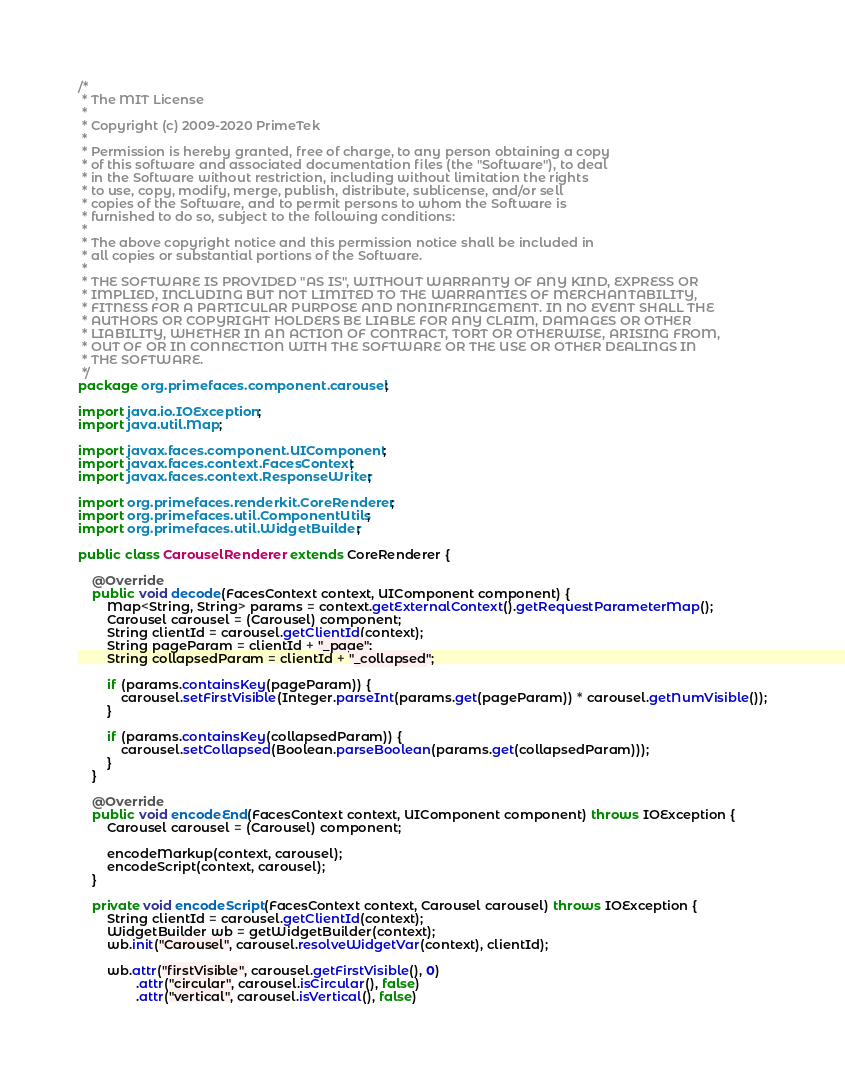<code> <loc_0><loc_0><loc_500><loc_500><_Java_>/*
 * The MIT License
 *
 * Copyright (c) 2009-2020 PrimeTek
 *
 * Permission is hereby granted, free of charge, to any person obtaining a copy
 * of this software and associated documentation files (the "Software"), to deal
 * in the Software without restriction, including without limitation the rights
 * to use, copy, modify, merge, publish, distribute, sublicense, and/or sell
 * copies of the Software, and to permit persons to whom the Software is
 * furnished to do so, subject to the following conditions:
 *
 * The above copyright notice and this permission notice shall be included in
 * all copies or substantial portions of the Software.
 *
 * THE SOFTWARE IS PROVIDED "AS IS", WITHOUT WARRANTY OF ANY KIND, EXPRESS OR
 * IMPLIED, INCLUDING BUT NOT LIMITED TO THE WARRANTIES OF MERCHANTABILITY,
 * FITNESS FOR A PARTICULAR PURPOSE AND NONINFRINGEMENT. IN NO EVENT SHALL THE
 * AUTHORS OR COPYRIGHT HOLDERS BE LIABLE FOR ANY CLAIM, DAMAGES OR OTHER
 * LIABILITY, WHETHER IN AN ACTION OF CONTRACT, TORT OR OTHERWISE, ARISING FROM,
 * OUT OF OR IN CONNECTION WITH THE SOFTWARE OR THE USE OR OTHER DEALINGS IN
 * THE SOFTWARE.
 */
package org.primefaces.component.carousel;

import java.io.IOException;
import java.util.Map;

import javax.faces.component.UIComponent;
import javax.faces.context.FacesContext;
import javax.faces.context.ResponseWriter;

import org.primefaces.renderkit.CoreRenderer;
import org.primefaces.util.ComponentUtils;
import org.primefaces.util.WidgetBuilder;

public class CarouselRenderer extends CoreRenderer {

    @Override
    public void decode(FacesContext context, UIComponent component) {
        Map<String, String> params = context.getExternalContext().getRequestParameterMap();
        Carousel carousel = (Carousel) component;
        String clientId = carousel.getClientId(context);
        String pageParam = clientId + "_page";
        String collapsedParam = clientId + "_collapsed";

        if (params.containsKey(pageParam)) {
            carousel.setFirstVisible(Integer.parseInt(params.get(pageParam)) * carousel.getNumVisible());
        }

        if (params.containsKey(collapsedParam)) {
            carousel.setCollapsed(Boolean.parseBoolean(params.get(collapsedParam)));
        }
    }

    @Override
    public void encodeEnd(FacesContext context, UIComponent component) throws IOException {
        Carousel carousel = (Carousel) component;

        encodeMarkup(context, carousel);
        encodeScript(context, carousel);
    }

    private void encodeScript(FacesContext context, Carousel carousel) throws IOException {
        String clientId = carousel.getClientId(context);
        WidgetBuilder wb = getWidgetBuilder(context);
        wb.init("Carousel", carousel.resolveWidgetVar(context), clientId);

        wb.attr("firstVisible", carousel.getFirstVisible(), 0)
                .attr("circular", carousel.isCircular(), false)
                .attr("vertical", carousel.isVertical(), false)</code> 